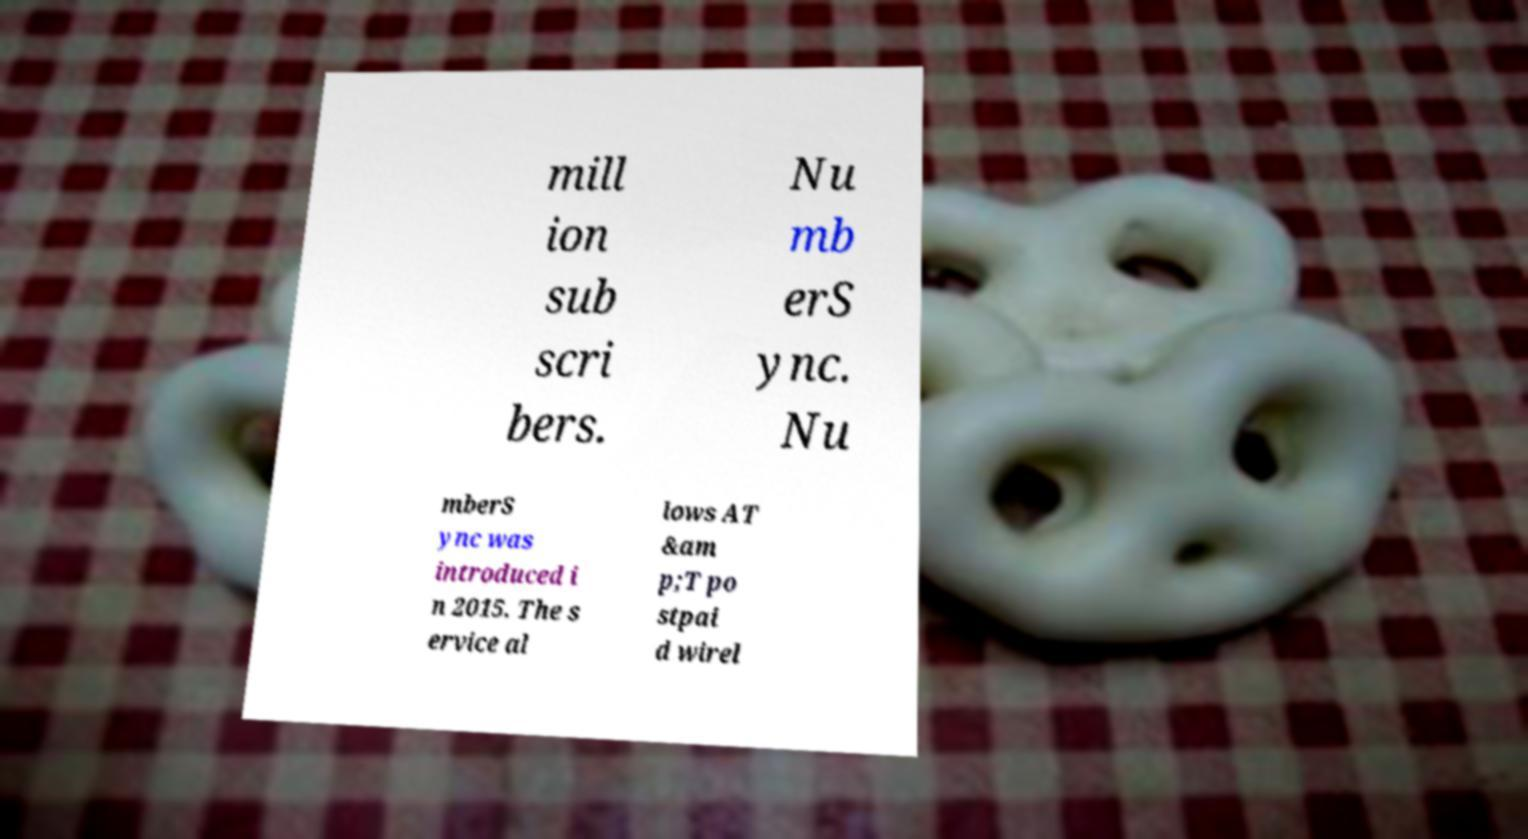What messages or text are displayed in this image? I need them in a readable, typed format. mill ion sub scri bers. Nu mb erS ync. Nu mberS ync was introduced i n 2015. The s ervice al lows AT &am p;T po stpai d wirel 